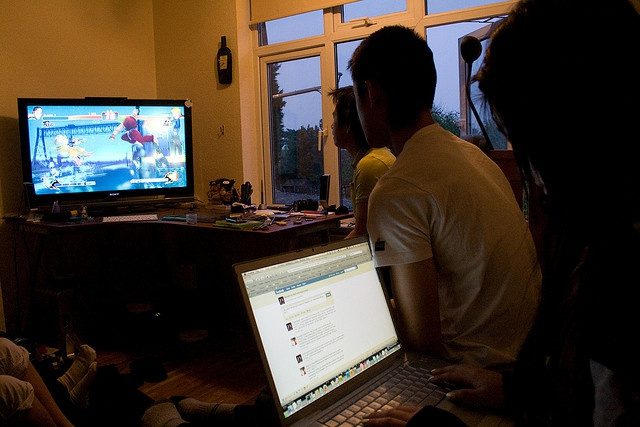Describe the objects in this image and their specific colors. I can see people in olive, black, maroon, and gray tones, people in olive, black, maroon, and gray tones, laptop in olive, lightgray, black, and darkgray tones, tv in olive, black, lightblue, and white tones, and keyboard in olive, black, maroon, and gray tones in this image. 